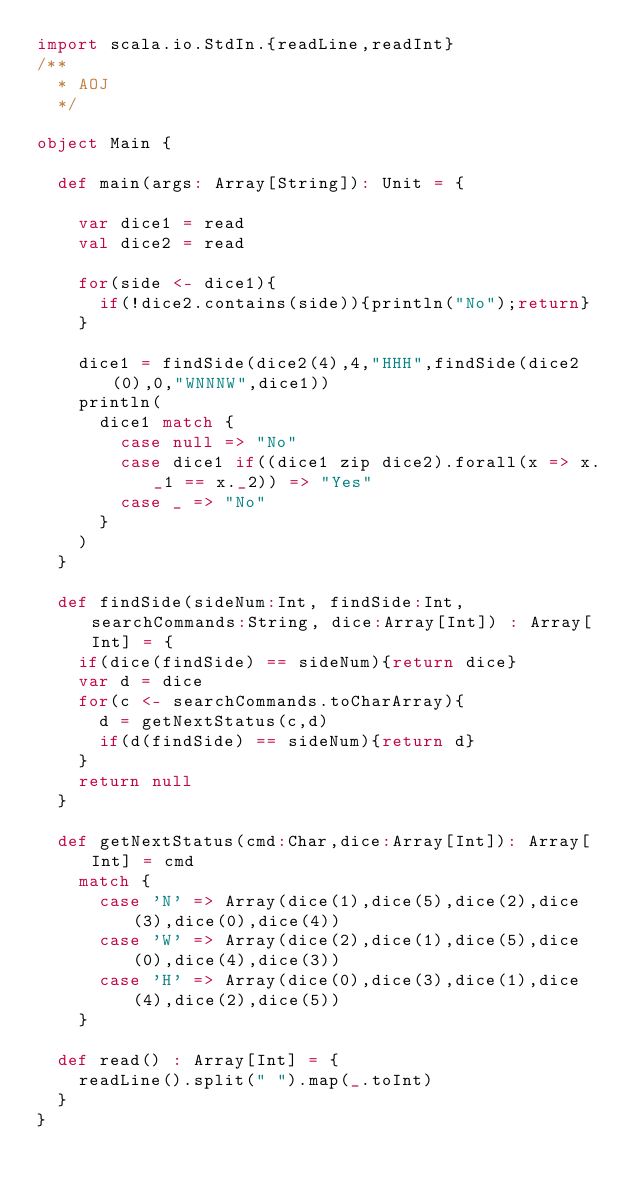<code> <loc_0><loc_0><loc_500><loc_500><_Scala_>import scala.io.StdIn.{readLine,readInt}
/**
  * AOJ
  */

object Main {

  def main(args: Array[String]): Unit = {

    var dice1 = read
    val dice2 = read

    for(side <- dice1){
      if(!dice2.contains(side)){println("No");return}
    }

    dice1 = findSide(dice2(4),4,"HHH",findSide(dice2(0),0,"WNNNW",dice1))
    println(
      dice1 match {
        case null => "No"
        case dice1 if((dice1 zip dice2).forall(x => x._1 == x._2)) => "Yes"
        case _ => "No"
      }
    )
  }

  def findSide(sideNum:Int, findSide:Int, searchCommands:String, dice:Array[Int]) : Array[Int] = {
    if(dice(findSide) == sideNum){return dice}
    var d = dice
    for(c <- searchCommands.toCharArray){
      d = getNextStatus(c,d)
      if(d(findSide) == sideNum){return d}
    }
    return null
  }

  def getNextStatus(cmd:Char,dice:Array[Int]): Array[Int] = cmd
    match {
      case 'N' => Array(dice(1),dice(5),dice(2),dice(3),dice(0),dice(4))
      case 'W' => Array(dice(2),dice(1),dice(5),dice(0),dice(4),dice(3))
      case 'H' => Array(dice(0),dice(3),dice(1),dice(4),dice(2),dice(5))
    }

  def read() : Array[Int] = {
    readLine().split(" ").map(_.toInt)
  }
}</code> 